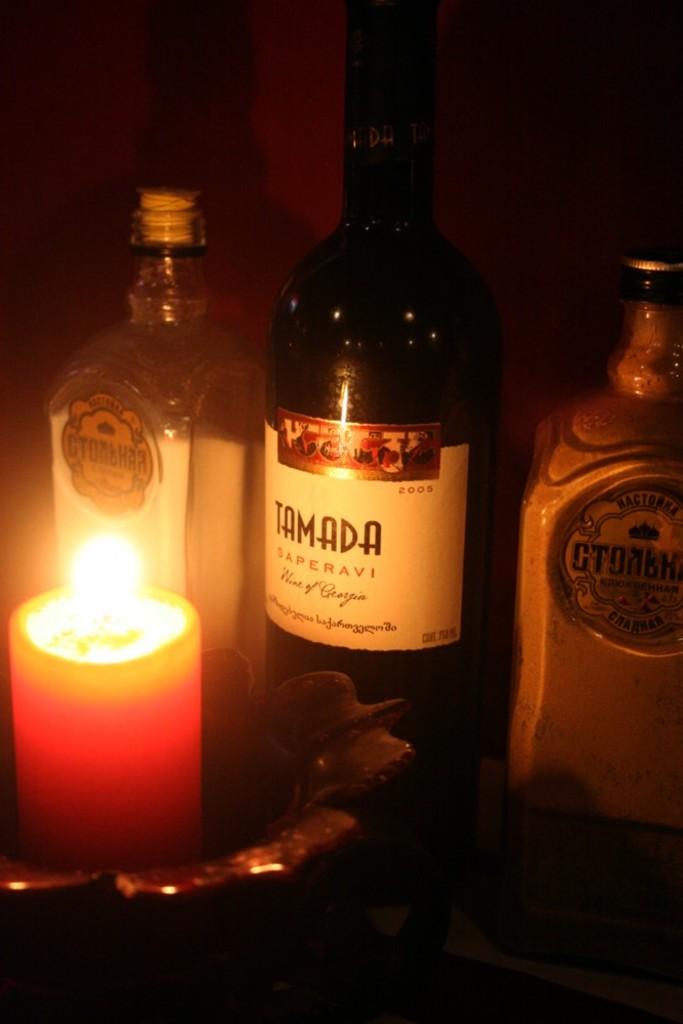What is in the middle bottle?
Offer a terse response. Tamada. What is the brand of the middle bottle?
Offer a very short reply. Tamada. 